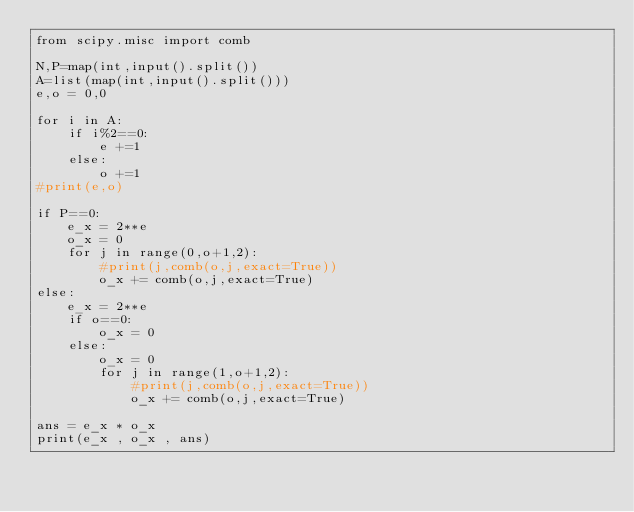Convert code to text. <code><loc_0><loc_0><loc_500><loc_500><_Python_>from scipy.misc import comb

N,P=map(int,input().split())
A=list(map(int,input().split()))
e,o = 0,0

for i in A:
    if i%2==0:
        e +=1
    else:
        o +=1
#print(e,o)
       
if P==0:
    e_x = 2**e
    o_x = 0
    for j in range(0,o+1,2):
        #print(j,comb(o,j,exact=True))
        o_x += comb(o,j,exact=True)
else:
    e_x = 2**e
    if o==0:
        o_x = 0
    else:
        o_x = 0
        for j in range(1,o+1,2):
            #print(j,comb(o,j,exact=True))
            o_x += comb(o,j,exact=True)

ans = e_x * o_x
print(e_x , o_x , ans)        
</code> 